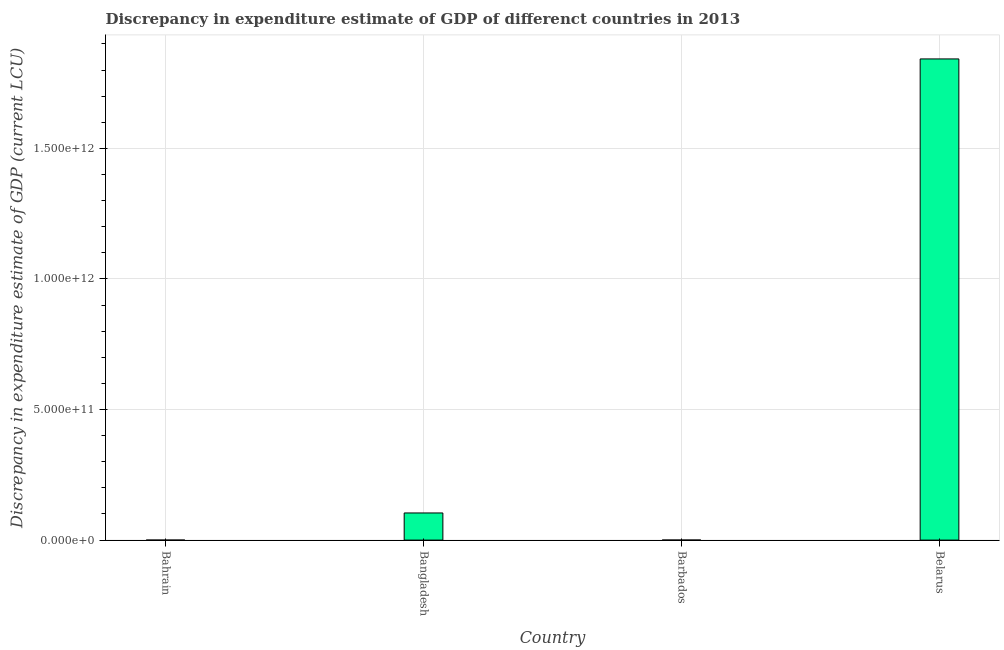What is the title of the graph?
Offer a terse response. Discrepancy in expenditure estimate of GDP of differenct countries in 2013. What is the label or title of the Y-axis?
Offer a very short reply. Discrepancy in expenditure estimate of GDP (current LCU). What is the discrepancy in expenditure estimate of gdp in Bangladesh?
Keep it short and to the point. 1.04e+11. Across all countries, what is the maximum discrepancy in expenditure estimate of gdp?
Offer a very short reply. 1.84e+12. In which country was the discrepancy in expenditure estimate of gdp maximum?
Provide a short and direct response. Belarus. What is the sum of the discrepancy in expenditure estimate of gdp?
Make the answer very short. 1.95e+12. What is the difference between the discrepancy in expenditure estimate of gdp in Bangladesh and Belarus?
Your response must be concise. -1.74e+12. What is the average discrepancy in expenditure estimate of gdp per country?
Offer a very short reply. 4.87e+11. What is the median discrepancy in expenditure estimate of gdp?
Ensure brevity in your answer.  5.21e+1. What is the ratio of the discrepancy in expenditure estimate of gdp in Bangladesh to that in Belarus?
Provide a short and direct response. 0.06. Is the discrepancy in expenditure estimate of gdp in Bangladesh less than that in Belarus?
Make the answer very short. Yes. Is the difference between the discrepancy in expenditure estimate of gdp in Barbados and Belarus greater than the difference between any two countries?
Provide a short and direct response. No. What is the difference between the highest and the second highest discrepancy in expenditure estimate of gdp?
Your response must be concise. 1.74e+12. Is the sum of the discrepancy in expenditure estimate of gdp in Bangladesh and Barbados greater than the maximum discrepancy in expenditure estimate of gdp across all countries?
Your answer should be compact. No. What is the difference between the highest and the lowest discrepancy in expenditure estimate of gdp?
Your answer should be very brief. 1.84e+12. How many countries are there in the graph?
Keep it short and to the point. 4. What is the difference between two consecutive major ticks on the Y-axis?
Offer a very short reply. 5.00e+11. Are the values on the major ticks of Y-axis written in scientific E-notation?
Offer a terse response. Yes. What is the Discrepancy in expenditure estimate of GDP (current LCU) in Bangladesh?
Your answer should be very brief. 1.04e+11. What is the Discrepancy in expenditure estimate of GDP (current LCU) in Barbados?
Provide a short and direct response. 1.52e+08. What is the Discrepancy in expenditure estimate of GDP (current LCU) in Belarus?
Make the answer very short. 1.84e+12. What is the difference between the Discrepancy in expenditure estimate of GDP (current LCU) in Bangladesh and Barbados?
Provide a succinct answer. 1.04e+11. What is the difference between the Discrepancy in expenditure estimate of GDP (current LCU) in Bangladesh and Belarus?
Offer a terse response. -1.74e+12. What is the difference between the Discrepancy in expenditure estimate of GDP (current LCU) in Barbados and Belarus?
Ensure brevity in your answer.  -1.84e+12. What is the ratio of the Discrepancy in expenditure estimate of GDP (current LCU) in Bangladesh to that in Barbados?
Your answer should be very brief. 683.96. What is the ratio of the Discrepancy in expenditure estimate of GDP (current LCU) in Bangladesh to that in Belarus?
Make the answer very short. 0.06. What is the ratio of the Discrepancy in expenditure estimate of GDP (current LCU) in Barbados to that in Belarus?
Offer a terse response. 0. 